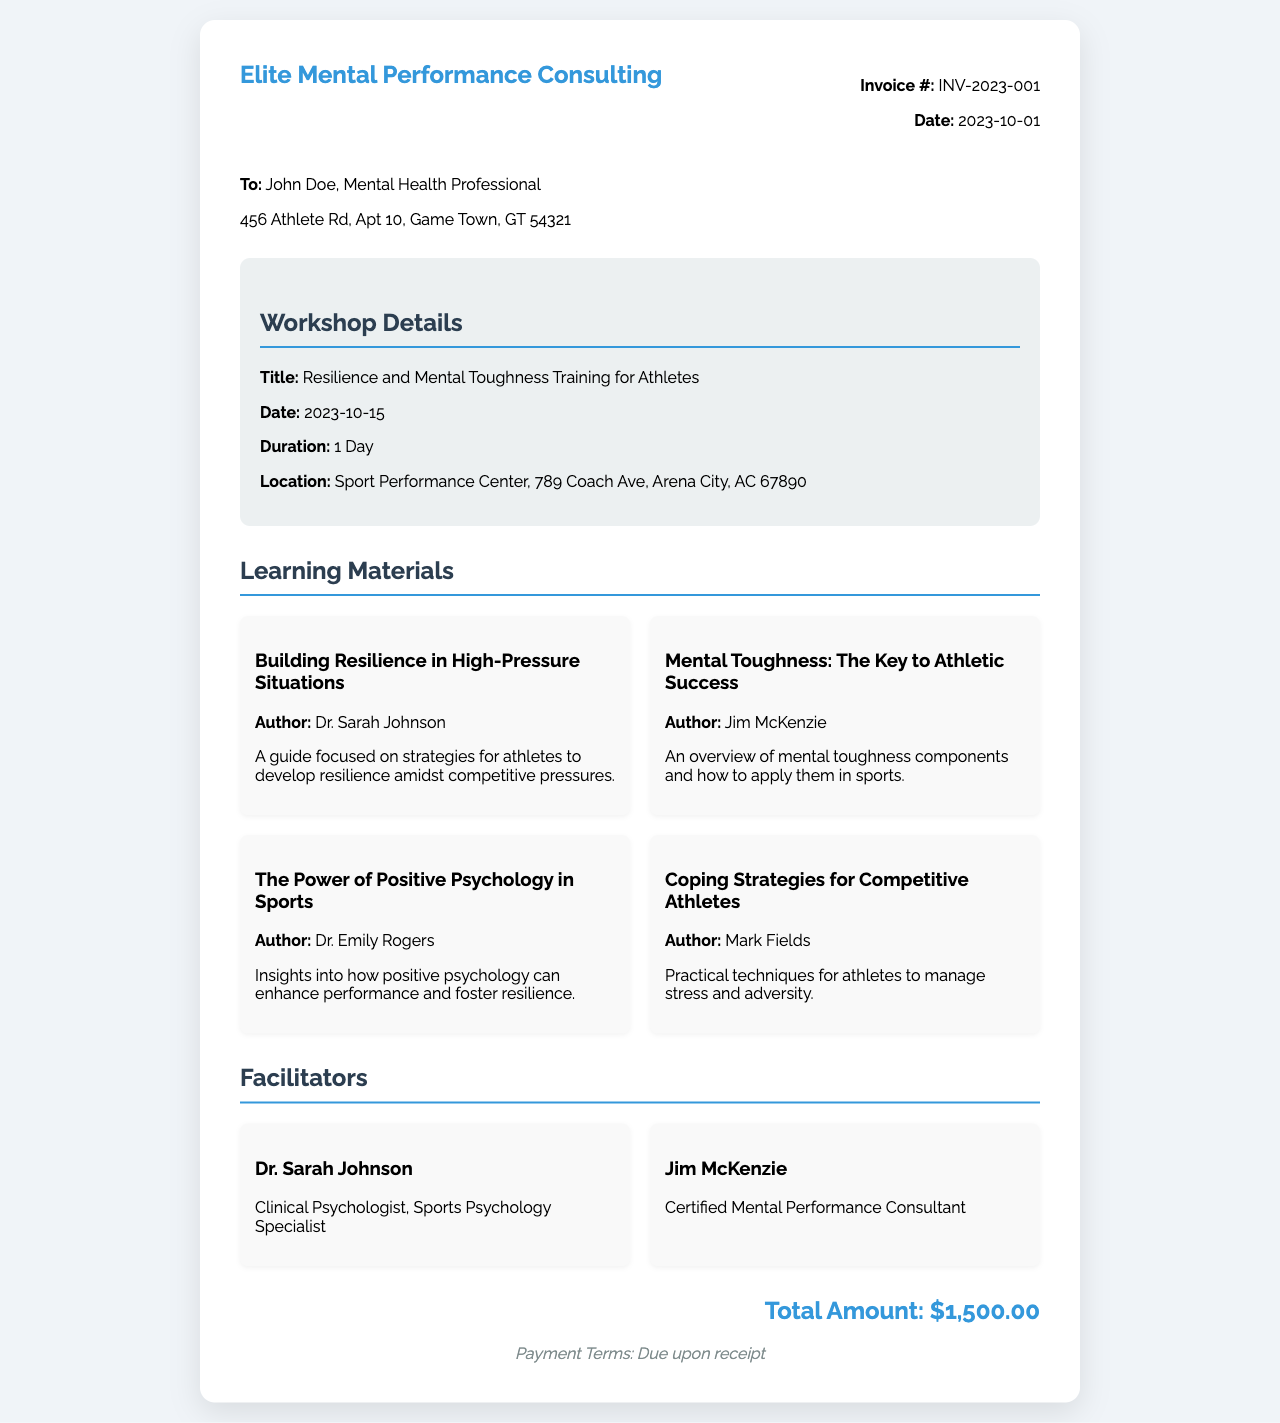What is the title of the workshop? The title of the workshop is explicitly stated in the document.
Answer: Resilience and Mental Toughness Training for Athletes Who is the client mentioned in the invoice? The invoice provides the name of the recipient as part of the client information.
Answer: John Doe What is the date of the workshop? The date of the workshop is clearly provided in the workshop details section.
Answer: 2023-10-15 How many learning materials are listed? The count of learning materials is derived by reviewing the materials section of the invoice.
Answer: 4 Who is one of the facilitators? The invoice lists facilitators, and one of their names can be referenced directly.
Answer: Dr. Sarah Johnson What is the total amount due on the invoice? The total amount is stated directly in the invoice as part of the billing information.
Answer: $1,500.00 What is the payment term? The document specifies payment terms towards the end, indicating when payment is due.
Answer: Due upon receipt Where is the workshop being held? The location of the workshop is detailed in the workshop information section.
Answer: Sport Performance Center, 789 Coach Ave, Arena City, AC 67890 What is the author's name for the second learning material? Each learning material has an associated author, which can be found in their respective sections.
Answer: Jim McKenzie 